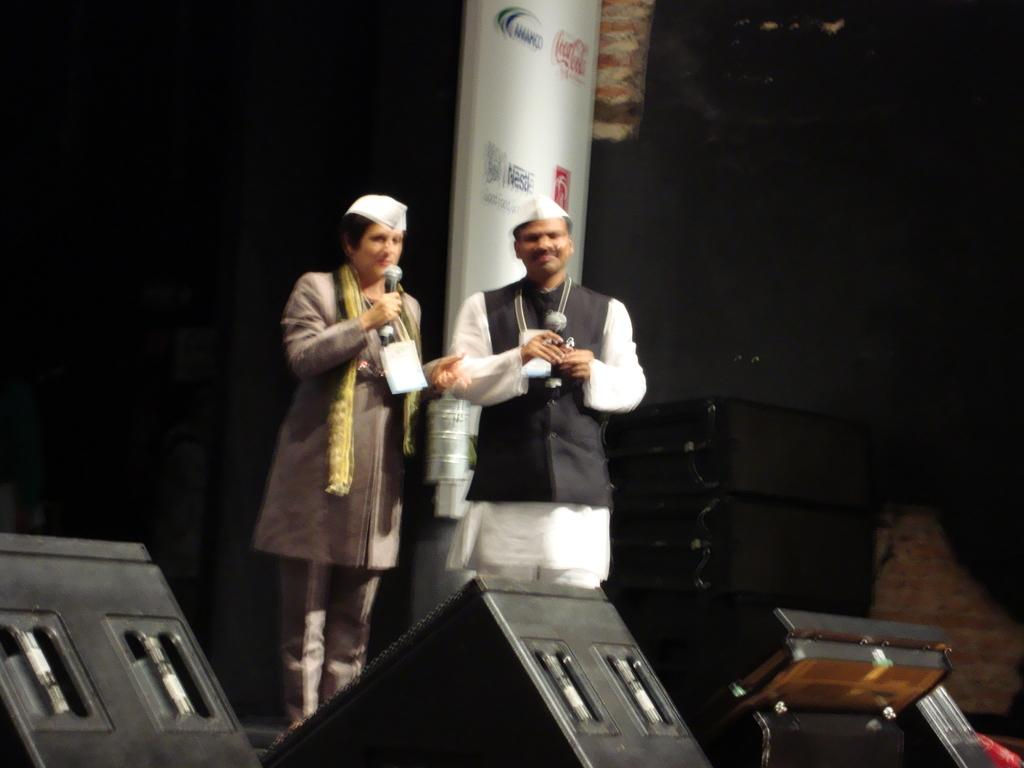How many people are in the image? There are two persons standing in the image. What objects can be seen in the image besides the people? There are speakers and a board in the image, as well as other objects. What is the color of the background in the image? The background of the image is dark. What type of plantation can be seen in the image? There is no plantation present in the image. 